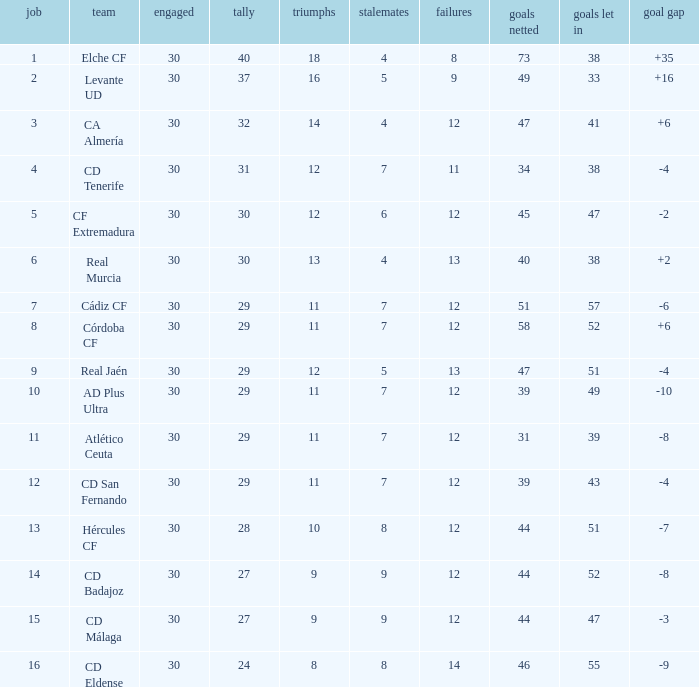What is the number of goals with less than 14 wins and a goal difference less than -4? 51, 39, 31, 44, 44, 46. 